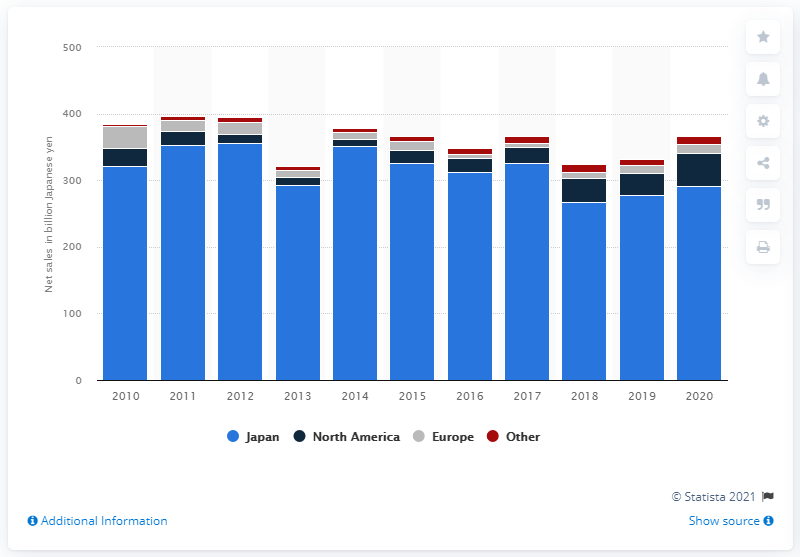Indicate a few pertinent items in this graphic. Sega Sammy's sales in North America in yen for the fiscal year ending March 31, 2020, were 49.03 yen. 